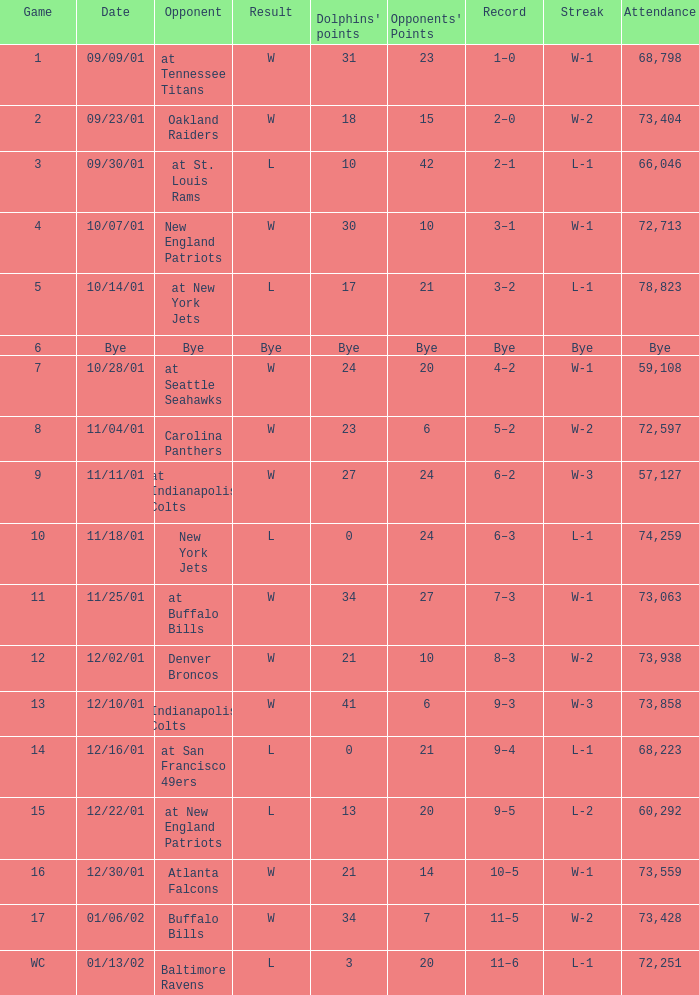What is the streak for game 2? W-2. 